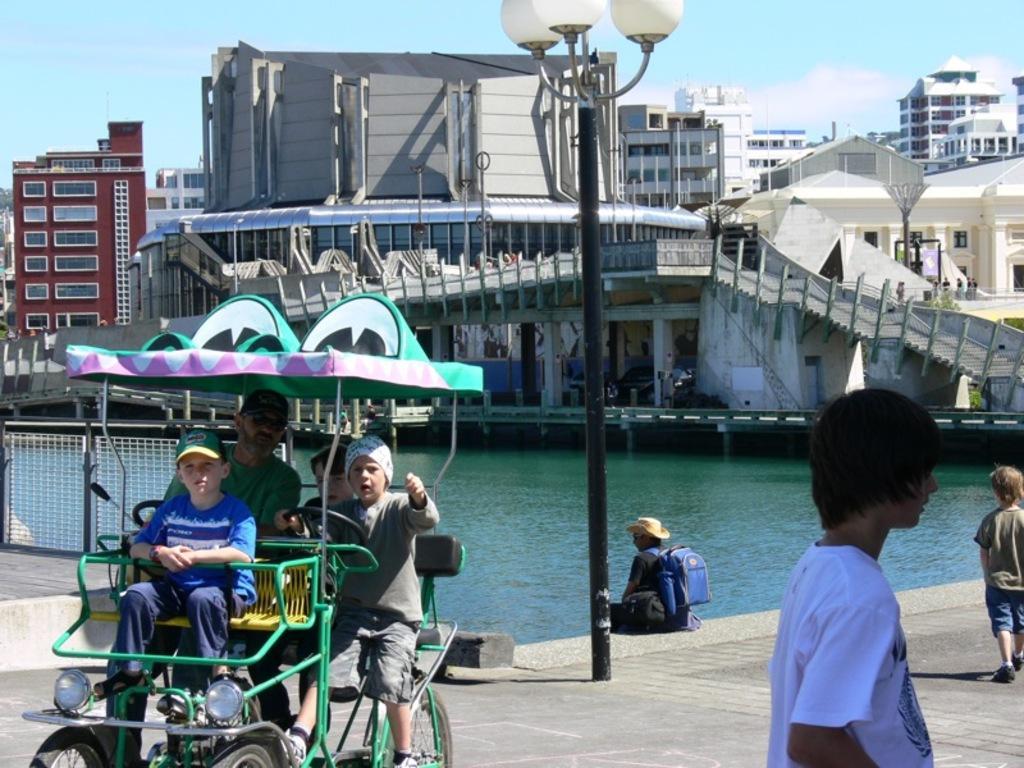Could you give a brief overview of what you see in this image? This picture is clicked outside. On the left we can see the group of people sitting in the vehicle, and on the right we can see the two people wearing t-shirts and seems to be walking on the ground and we can see a person wearing a hat, backpack and sitting on the ground and we can see the lamp post and a water body. In the background we can see the sky, buildings, stairway and some other items and the group of people. 